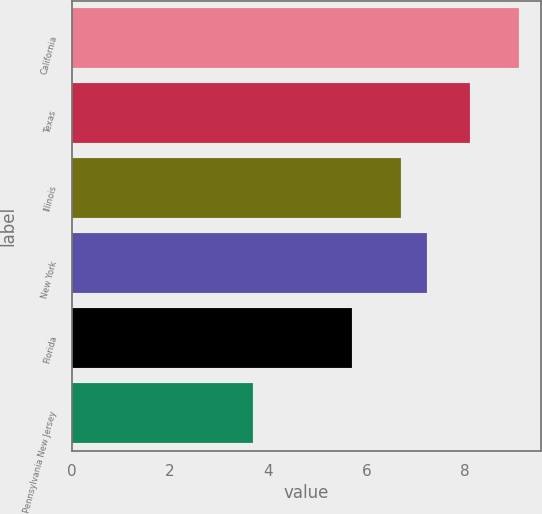Convert chart to OTSL. <chart><loc_0><loc_0><loc_500><loc_500><bar_chart><fcel>California<fcel>Texas<fcel>Illinois<fcel>New York<fcel>Florida<fcel>Pennsylvania New Jersey<nl><fcel>9.1<fcel>8.1<fcel>6.7<fcel>7.24<fcel>5.7<fcel>3.7<nl></chart> 